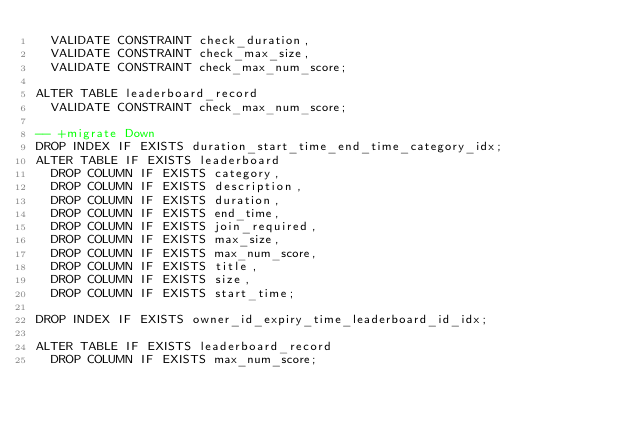Convert code to text. <code><loc_0><loc_0><loc_500><loc_500><_SQL_>  VALIDATE CONSTRAINT check_duration,
  VALIDATE CONSTRAINT check_max_size,
  VALIDATE CONSTRAINT check_max_num_score;

ALTER TABLE leaderboard_record
  VALIDATE CONSTRAINT check_max_num_score;

-- +migrate Down
DROP INDEX IF EXISTS duration_start_time_end_time_category_idx;
ALTER TABLE IF EXISTS leaderboard
  DROP COLUMN IF EXISTS category,
  DROP COLUMN IF EXISTS description,
  DROP COLUMN IF EXISTS duration,
  DROP COLUMN IF EXISTS end_time,
  DROP COLUMN IF EXISTS join_required,
  DROP COLUMN IF EXISTS max_size,
  DROP COLUMN IF EXISTS max_num_score,
  DROP COLUMN IF EXISTS title,
  DROP COLUMN IF EXISTS size,
  DROP COLUMN IF EXISTS start_time;

DROP INDEX IF EXISTS owner_id_expiry_time_leaderboard_id_idx;

ALTER TABLE IF EXISTS leaderboard_record
  DROP COLUMN IF EXISTS max_num_score;
</code> 